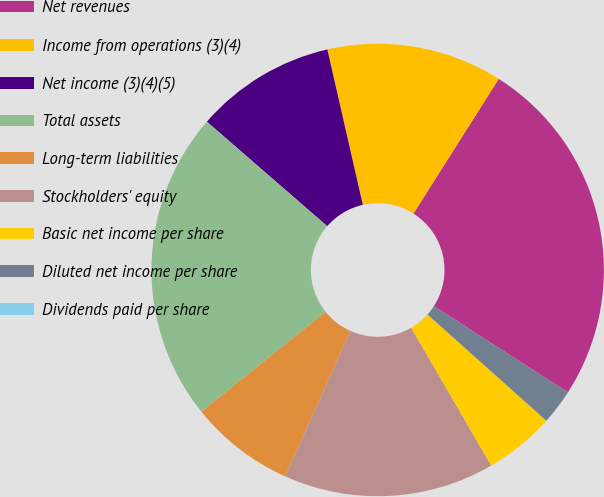Convert chart. <chart><loc_0><loc_0><loc_500><loc_500><pie_chart><fcel>Net revenues<fcel>Income from operations (3)(4)<fcel>Net income (3)(4)(5)<fcel>Total assets<fcel>Long-term liabilities<fcel>Stockholders' equity<fcel>Basic net income per share<fcel>Diluted net income per share<fcel>Dividends paid per share<nl><fcel>25.11%<fcel>12.56%<fcel>10.05%<fcel>22.15%<fcel>7.53%<fcel>15.07%<fcel>5.02%<fcel>2.51%<fcel>0.0%<nl></chart> 